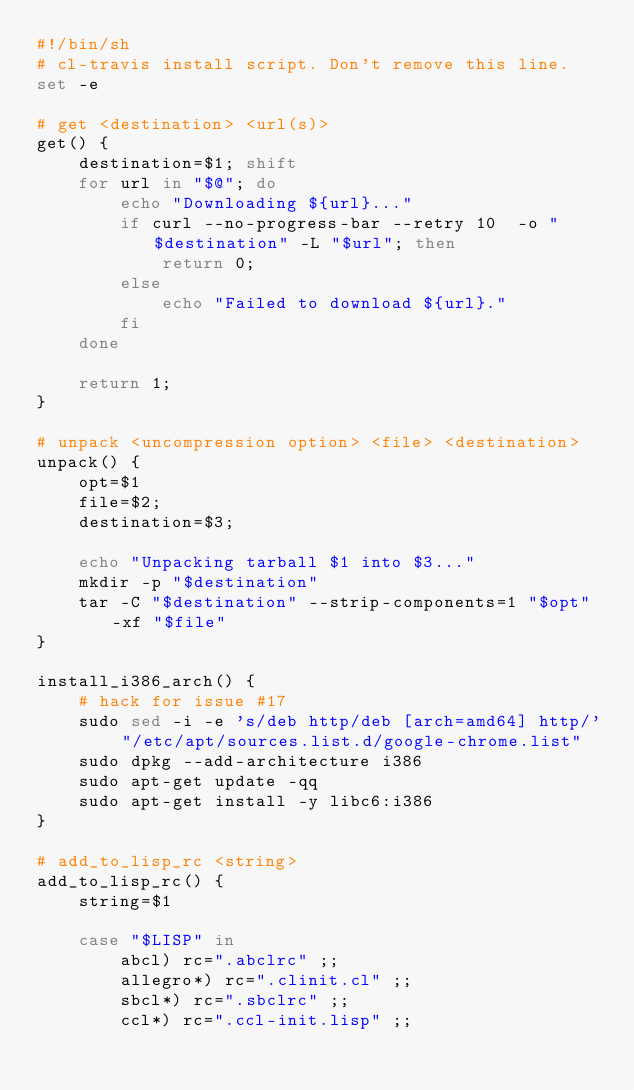Convert code to text. <code><loc_0><loc_0><loc_500><loc_500><_Bash_>#!/bin/sh
# cl-travis install script. Don't remove this line.
set -e

# get <destination> <url(s)>
get() {
    destination=$1; shift
    for url in "$@"; do
        echo "Downloading ${url}..."
        if curl --no-progress-bar --retry 10  -o "$destination" -L "$url"; then
            return 0;
        else
            echo "Failed to download ${url}."
        fi
    done

    return 1;
}

# unpack <uncompression option> <file> <destination>
unpack() {
    opt=$1
    file=$2;
    destination=$3;

    echo "Unpacking tarball $1 into $3..."
    mkdir -p "$destination"
    tar -C "$destination" --strip-components=1 "$opt" -xf "$file"
}

install_i386_arch() {
    # hack for issue #17
    sudo sed -i -e 's/deb http/deb [arch=amd64] http/' "/etc/apt/sources.list.d/google-chrome.list"
    sudo dpkg --add-architecture i386
    sudo apt-get update -qq
    sudo apt-get install -y libc6:i386
}

# add_to_lisp_rc <string>
add_to_lisp_rc() {
    string=$1

    case "$LISP" in
        abcl) rc=".abclrc" ;;
        allegro*) rc=".clinit.cl" ;;
        sbcl*) rc=".sbclrc" ;;
        ccl*) rc=".ccl-init.lisp" ;;</code> 